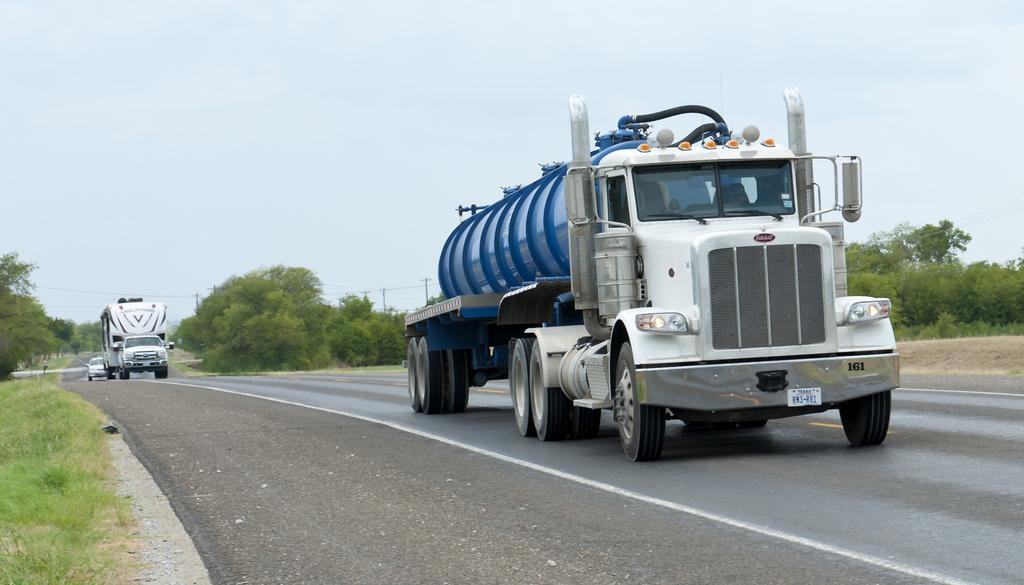What is the main subject of the image? The main subject of the image is a truck. What is the truck doing in the image? The truck is moving on the road in the image. Can you describe the color of the truck? The truck is white and blue in color. What type of natural scenery can be seen in the image? There are trees in the image. What is visible at the top of the image? The sky is visible at the top of the image. What type of can is visible on the throne in the image? There is no can or throne present in the image; it features a truck moving on the road. 